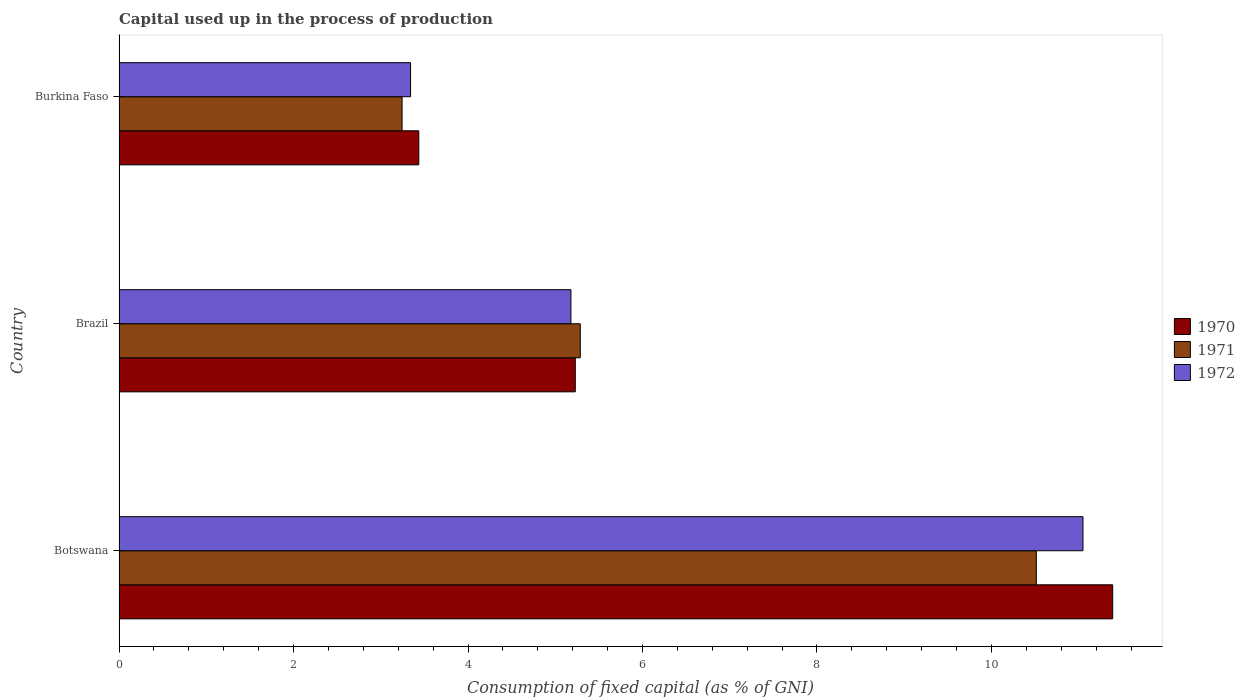Are the number of bars per tick equal to the number of legend labels?
Your answer should be very brief. Yes. Are the number of bars on each tick of the Y-axis equal?
Make the answer very short. Yes. How many bars are there on the 3rd tick from the top?
Provide a short and direct response. 3. How many bars are there on the 1st tick from the bottom?
Keep it short and to the point. 3. What is the label of the 1st group of bars from the top?
Your answer should be compact. Burkina Faso. In how many cases, is the number of bars for a given country not equal to the number of legend labels?
Provide a short and direct response. 0. What is the capital used up in the process of production in 1972 in Burkina Faso?
Provide a succinct answer. 3.34. Across all countries, what is the maximum capital used up in the process of production in 1971?
Your response must be concise. 10.51. Across all countries, what is the minimum capital used up in the process of production in 1971?
Offer a terse response. 3.24. In which country was the capital used up in the process of production in 1971 maximum?
Provide a short and direct response. Botswana. In which country was the capital used up in the process of production in 1971 minimum?
Offer a very short reply. Burkina Faso. What is the total capital used up in the process of production in 1970 in the graph?
Offer a terse response. 20.06. What is the difference between the capital used up in the process of production in 1972 in Botswana and that in Brazil?
Offer a very short reply. 5.87. What is the difference between the capital used up in the process of production in 1970 in Burkina Faso and the capital used up in the process of production in 1972 in Brazil?
Make the answer very short. -1.74. What is the average capital used up in the process of production in 1972 per country?
Give a very brief answer. 6.52. What is the difference between the capital used up in the process of production in 1972 and capital used up in the process of production in 1970 in Burkina Faso?
Give a very brief answer. -0.09. What is the ratio of the capital used up in the process of production in 1970 in Botswana to that in Brazil?
Provide a short and direct response. 2.18. Is the capital used up in the process of production in 1971 in Botswana less than that in Brazil?
Make the answer very short. No. Is the difference between the capital used up in the process of production in 1972 in Botswana and Burkina Faso greater than the difference between the capital used up in the process of production in 1970 in Botswana and Burkina Faso?
Your answer should be very brief. No. What is the difference between the highest and the second highest capital used up in the process of production in 1971?
Make the answer very short. 5.23. What is the difference between the highest and the lowest capital used up in the process of production in 1972?
Ensure brevity in your answer.  7.71. In how many countries, is the capital used up in the process of production in 1970 greater than the average capital used up in the process of production in 1970 taken over all countries?
Give a very brief answer. 1. What does the 1st bar from the top in Brazil represents?
Provide a short and direct response. 1972. What does the 1st bar from the bottom in Brazil represents?
Your response must be concise. 1970. Is it the case that in every country, the sum of the capital used up in the process of production in 1970 and capital used up in the process of production in 1971 is greater than the capital used up in the process of production in 1972?
Offer a terse response. Yes. Are all the bars in the graph horizontal?
Provide a short and direct response. Yes. How many countries are there in the graph?
Your answer should be very brief. 3. What is the difference between two consecutive major ticks on the X-axis?
Ensure brevity in your answer.  2. Are the values on the major ticks of X-axis written in scientific E-notation?
Your response must be concise. No. Does the graph contain grids?
Give a very brief answer. No. How are the legend labels stacked?
Provide a succinct answer. Vertical. What is the title of the graph?
Your answer should be compact. Capital used up in the process of production. Does "2010" appear as one of the legend labels in the graph?
Offer a terse response. No. What is the label or title of the X-axis?
Make the answer very short. Consumption of fixed capital (as % of GNI). What is the label or title of the Y-axis?
Provide a succinct answer. Country. What is the Consumption of fixed capital (as % of GNI) of 1970 in Botswana?
Give a very brief answer. 11.39. What is the Consumption of fixed capital (as % of GNI) in 1971 in Botswana?
Ensure brevity in your answer.  10.51. What is the Consumption of fixed capital (as % of GNI) in 1972 in Botswana?
Make the answer very short. 11.05. What is the Consumption of fixed capital (as % of GNI) of 1970 in Brazil?
Offer a terse response. 5.23. What is the Consumption of fixed capital (as % of GNI) of 1971 in Brazil?
Offer a terse response. 5.29. What is the Consumption of fixed capital (as % of GNI) in 1972 in Brazil?
Make the answer very short. 5.18. What is the Consumption of fixed capital (as % of GNI) in 1970 in Burkina Faso?
Your answer should be very brief. 3.44. What is the Consumption of fixed capital (as % of GNI) of 1971 in Burkina Faso?
Give a very brief answer. 3.24. What is the Consumption of fixed capital (as % of GNI) of 1972 in Burkina Faso?
Your answer should be very brief. 3.34. Across all countries, what is the maximum Consumption of fixed capital (as % of GNI) in 1970?
Offer a very short reply. 11.39. Across all countries, what is the maximum Consumption of fixed capital (as % of GNI) in 1971?
Ensure brevity in your answer.  10.51. Across all countries, what is the maximum Consumption of fixed capital (as % of GNI) of 1972?
Provide a short and direct response. 11.05. Across all countries, what is the minimum Consumption of fixed capital (as % of GNI) of 1970?
Give a very brief answer. 3.44. Across all countries, what is the minimum Consumption of fixed capital (as % of GNI) in 1971?
Your answer should be very brief. 3.24. Across all countries, what is the minimum Consumption of fixed capital (as % of GNI) in 1972?
Provide a short and direct response. 3.34. What is the total Consumption of fixed capital (as % of GNI) of 1970 in the graph?
Give a very brief answer. 20.06. What is the total Consumption of fixed capital (as % of GNI) in 1971 in the graph?
Offer a very short reply. 19.05. What is the total Consumption of fixed capital (as % of GNI) in 1972 in the graph?
Your response must be concise. 19.57. What is the difference between the Consumption of fixed capital (as % of GNI) of 1970 in Botswana and that in Brazil?
Offer a terse response. 6.16. What is the difference between the Consumption of fixed capital (as % of GNI) in 1971 in Botswana and that in Brazil?
Provide a short and direct response. 5.23. What is the difference between the Consumption of fixed capital (as % of GNI) in 1972 in Botswana and that in Brazil?
Your answer should be very brief. 5.87. What is the difference between the Consumption of fixed capital (as % of GNI) of 1970 in Botswana and that in Burkina Faso?
Keep it short and to the point. 7.95. What is the difference between the Consumption of fixed capital (as % of GNI) in 1971 in Botswana and that in Burkina Faso?
Provide a succinct answer. 7.27. What is the difference between the Consumption of fixed capital (as % of GNI) in 1972 in Botswana and that in Burkina Faso?
Your answer should be very brief. 7.71. What is the difference between the Consumption of fixed capital (as % of GNI) of 1970 in Brazil and that in Burkina Faso?
Your answer should be compact. 1.79. What is the difference between the Consumption of fixed capital (as % of GNI) in 1971 in Brazil and that in Burkina Faso?
Your response must be concise. 2.04. What is the difference between the Consumption of fixed capital (as % of GNI) in 1972 in Brazil and that in Burkina Faso?
Provide a succinct answer. 1.84. What is the difference between the Consumption of fixed capital (as % of GNI) of 1970 in Botswana and the Consumption of fixed capital (as % of GNI) of 1971 in Brazil?
Offer a very short reply. 6.1. What is the difference between the Consumption of fixed capital (as % of GNI) of 1970 in Botswana and the Consumption of fixed capital (as % of GNI) of 1972 in Brazil?
Keep it short and to the point. 6.21. What is the difference between the Consumption of fixed capital (as % of GNI) in 1971 in Botswana and the Consumption of fixed capital (as % of GNI) in 1972 in Brazil?
Your answer should be compact. 5.33. What is the difference between the Consumption of fixed capital (as % of GNI) in 1970 in Botswana and the Consumption of fixed capital (as % of GNI) in 1971 in Burkina Faso?
Ensure brevity in your answer.  8.15. What is the difference between the Consumption of fixed capital (as % of GNI) in 1970 in Botswana and the Consumption of fixed capital (as % of GNI) in 1972 in Burkina Faso?
Offer a very short reply. 8.05. What is the difference between the Consumption of fixed capital (as % of GNI) of 1971 in Botswana and the Consumption of fixed capital (as % of GNI) of 1972 in Burkina Faso?
Offer a very short reply. 7.17. What is the difference between the Consumption of fixed capital (as % of GNI) in 1970 in Brazil and the Consumption of fixed capital (as % of GNI) in 1971 in Burkina Faso?
Provide a succinct answer. 1.99. What is the difference between the Consumption of fixed capital (as % of GNI) in 1970 in Brazil and the Consumption of fixed capital (as % of GNI) in 1972 in Burkina Faso?
Provide a succinct answer. 1.89. What is the difference between the Consumption of fixed capital (as % of GNI) in 1971 in Brazil and the Consumption of fixed capital (as % of GNI) in 1972 in Burkina Faso?
Your answer should be compact. 1.95. What is the average Consumption of fixed capital (as % of GNI) in 1970 per country?
Your answer should be compact. 6.69. What is the average Consumption of fixed capital (as % of GNI) of 1971 per country?
Give a very brief answer. 6.35. What is the average Consumption of fixed capital (as % of GNI) of 1972 per country?
Offer a terse response. 6.52. What is the difference between the Consumption of fixed capital (as % of GNI) of 1970 and Consumption of fixed capital (as % of GNI) of 1971 in Botswana?
Your answer should be very brief. 0.88. What is the difference between the Consumption of fixed capital (as % of GNI) of 1970 and Consumption of fixed capital (as % of GNI) of 1972 in Botswana?
Provide a succinct answer. 0.34. What is the difference between the Consumption of fixed capital (as % of GNI) in 1971 and Consumption of fixed capital (as % of GNI) in 1972 in Botswana?
Give a very brief answer. -0.54. What is the difference between the Consumption of fixed capital (as % of GNI) of 1970 and Consumption of fixed capital (as % of GNI) of 1971 in Brazil?
Offer a terse response. -0.06. What is the difference between the Consumption of fixed capital (as % of GNI) in 1970 and Consumption of fixed capital (as % of GNI) in 1972 in Brazil?
Ensure brevity in your answer.  0.05. What is the difference between the Consumption of fixed capital (as % of GNI) of 1971 and Consumption of fixed capital (as % of GNI) of 1972 in Brazil?
Ensure brevity in your answer.  0.11. What is the difference between the Consumption of fixed capital (as % of GNI) of 1970 and Consumption of fixed capital (as % of GNI) of 1971 in Burkina Faso?
Offer a very short reply. 0.19. What is the difference between the Consumption of fixed capital (as % of GNI) in 1970 and Consumption of fixed capital (as % of GNI) in 1972 in Burkina Faso?
Ensure brevity in your answer.  0.09. What is the difference between the Consumption of fixed capital (as % of GNI) in 1971 and Consumption of fixed capital (as % of GNI) in 1972 in Burkina Faso?
Offer a very short reply. -0.1. What is the ratio of the Consumption of fixed capital (as % of GNI) in 1970 in Botswana to that in Brazil?
Your answer should be compact. 2.18. What is the ratio of the Consumption of fixed capital (as % of GNI) in 1971 in Botswana to that in Brazil?
Give a very brief answer. 1.99. What is the ratio of the Consumption of fixed capital (as % of GNI) in 1972 in Botswana to that in Brazil?
Ensure brevity in your answer.  2.13. What is the ratio of the Consumption of fixed capital (as % of GNI) in 1970 in Botswana to that in Burkina Faso?
Make the answer very short. 3.31. What is the ratio of the Consumption of fixed capital (as % of GNI) of 1971 in Botswana to that in Burkina Faso?
Your answer should be very brief. 3.24. What is the ratio of the Consumption of fixed capital (as % of GNI) in 1972 in Botswana to that in Burkina Faso?
Your answer should be compact. 3.31. What is the ratio of the Consumption of fixed capital (as % of GNI) of 1970 in Brazil to that in Burkina Faso?
Keep it short and to the point. 1.52. What is the ratio of the Consumption of fixed capital (as % of GNI) of 1971 in Brazil to that in Burkina Faso?
Ensure brevity in your answer.  1.63. What is the ratio of the Consumption of fixed capital (as % of GNI) of 1972 in Brazil to that in Burkina Faso?
Keep it short and to the point. 1.55. What is the difference between the highest and the second highest Consumption of fixed capital (as % of GNI) in 1970?
Make the answer very short. 6.16. What is the difference between the highest and the second highest Consumption of fixed capital (as % of GNI) of 1971?
Keep it short and to the point. 5.23. What is the difference between the highest and the second highest Consumption of fixed capital (as % of GNI) in 1972?
Offer a terse response. 5.87. What is the difference between the highest and the lowest Consumption of fixed capital (as % of GNI) of 1970?
Provide a short and direct response. 7.95. What is the difference between the highest and the lowest Consumption of fixed capital (as % of GNI) of 1971?
Make the answer very short. 7.27. What is the difference between the highest and the lowest Consumption of fixed capital (as % of GNI) in 1972?
Provide a short and direct response. 7.71. 